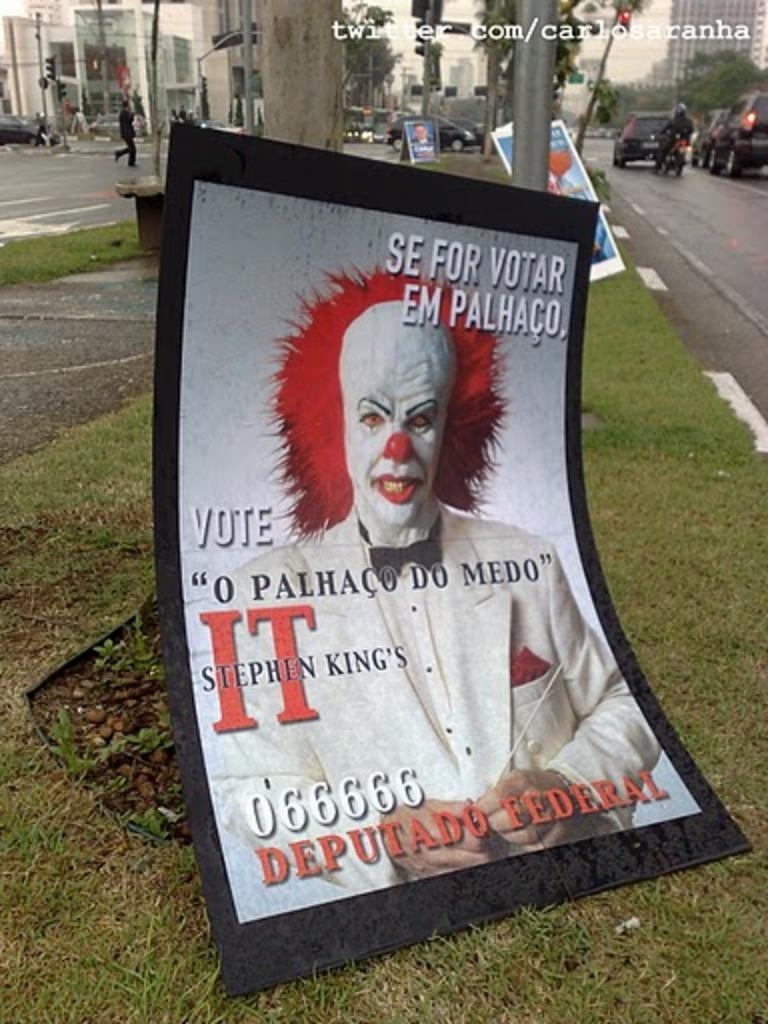<image>
Provide a brief description of the given image. A poster of Stephen King's It with a picture of Pennywise leaning against a pole in the grass. 